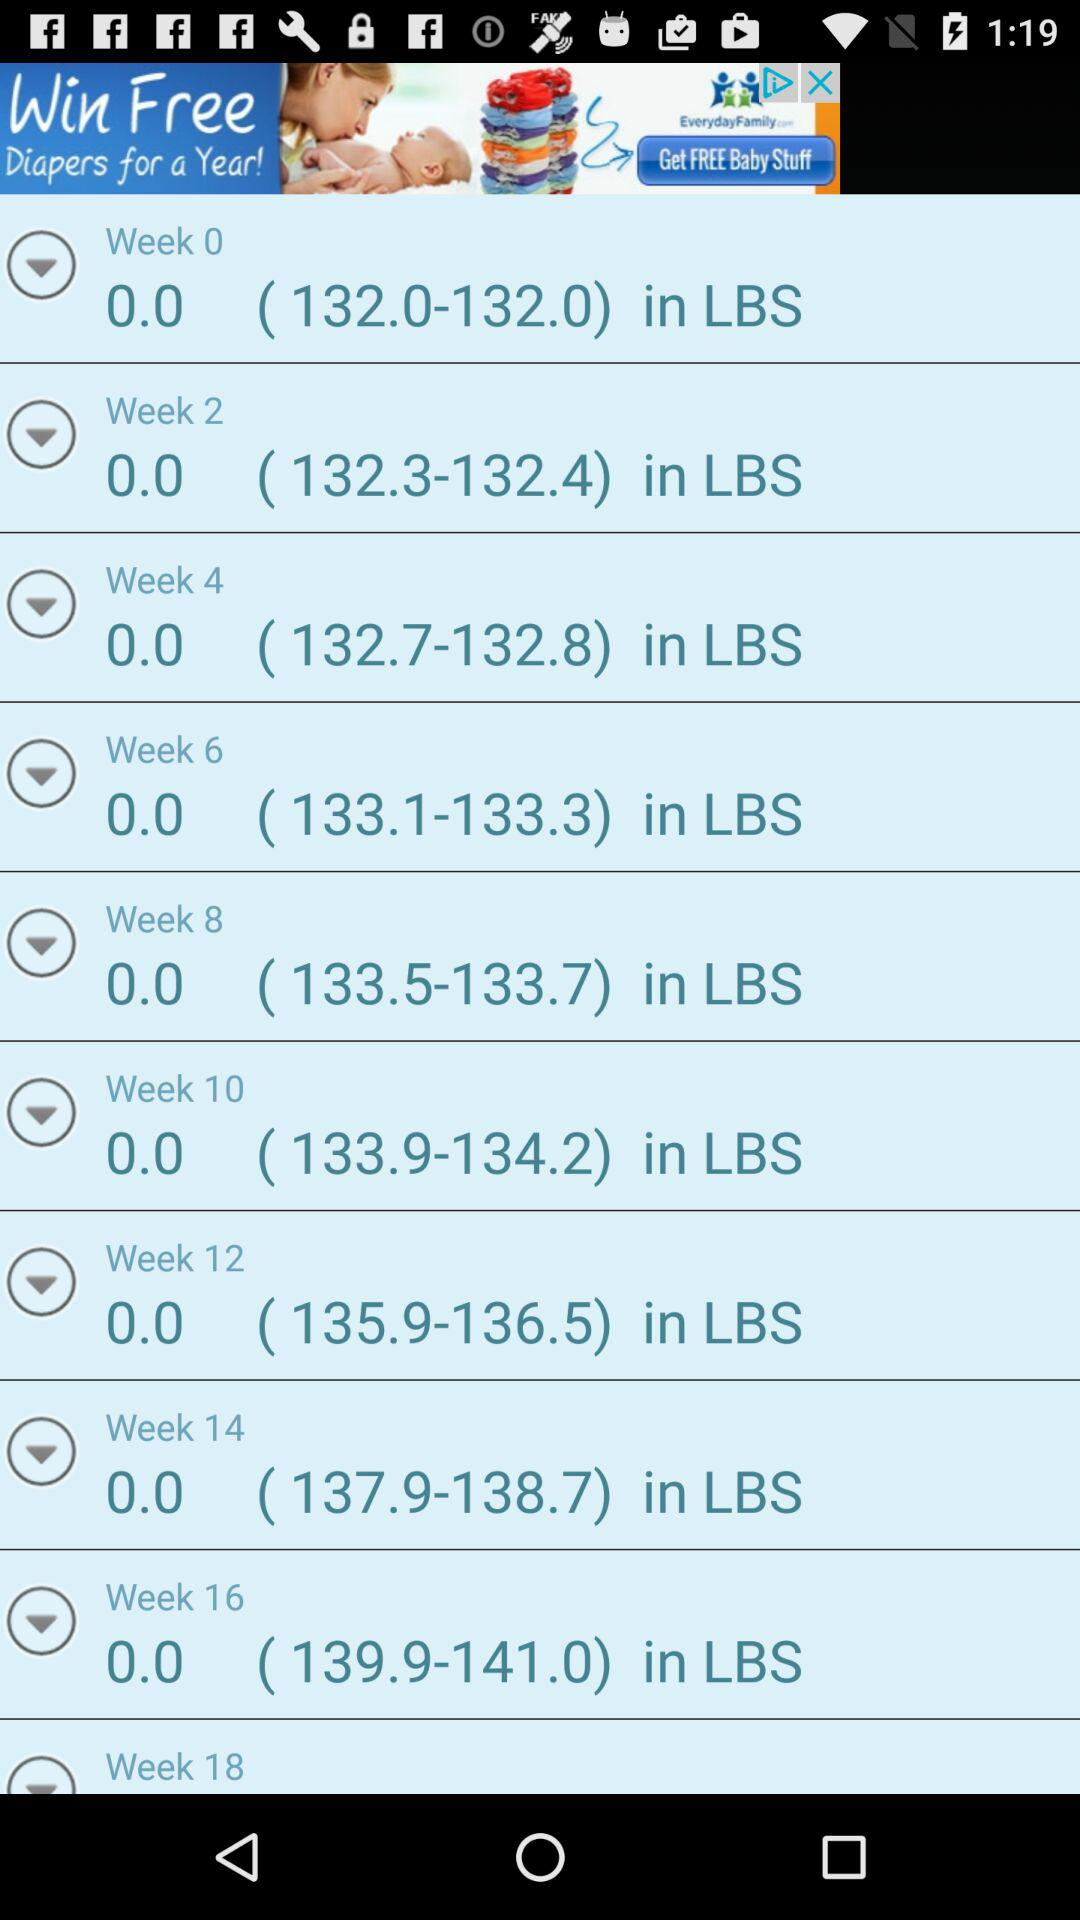What is the weight in lbs in the week 10 report? The weight in the week 10 report ranges from 133.9 lbs to 134.2 lbs. 